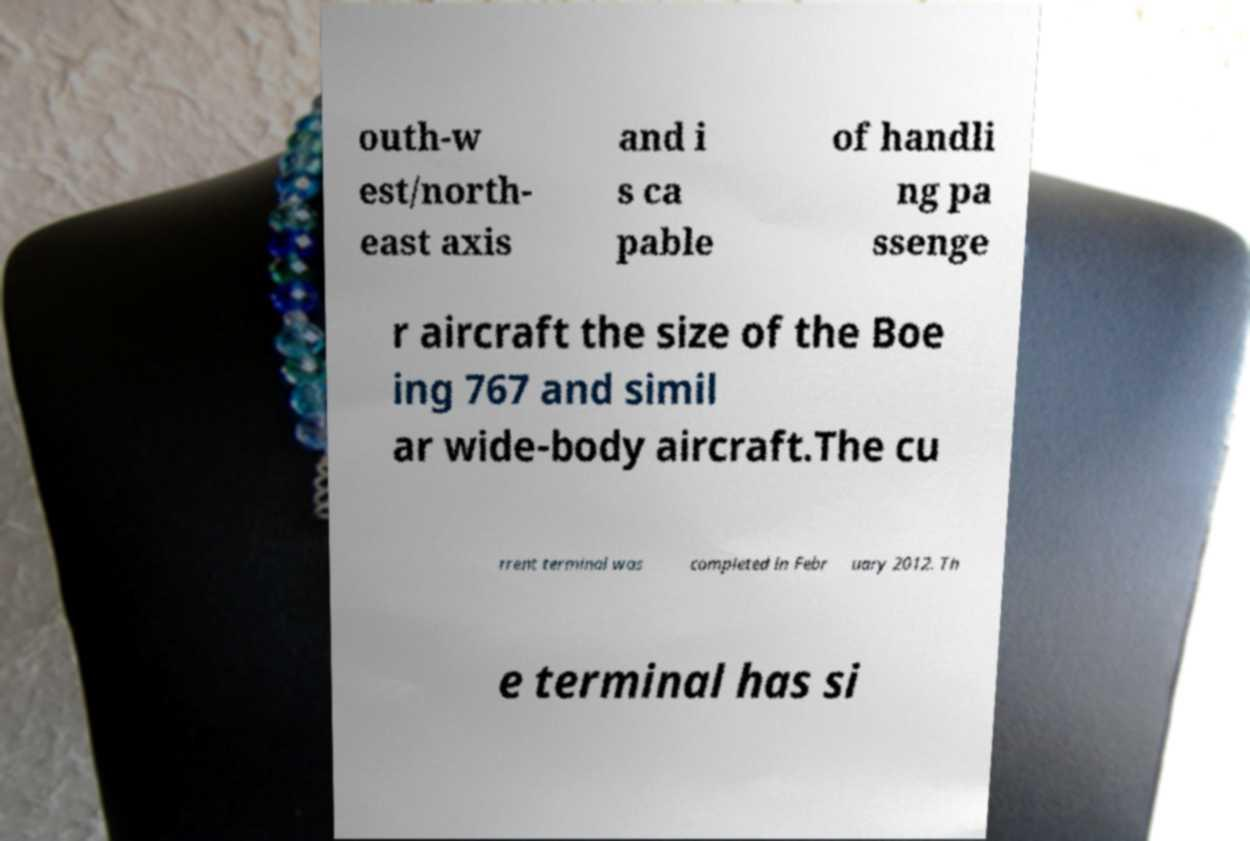What messages or text are displayed in this image? I need them in a readable, typed format. outh-w est/north- east axis and i s ca pable of handli ng pa ssenge r aircraft the size of the Boe ing 767 and simil ar wide-body aircraft.The cu rrent terminal was completed in Febr uary 2012. Th e terminal has si 